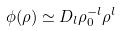Convert formula to latex. <formula><loc_0><loc_0><loc_500><loc_500>\phi ( \rho ) \simeq { D _ { l } \rho _ { 0 } ^ { - l } \rho ^ { l } }</formula> 